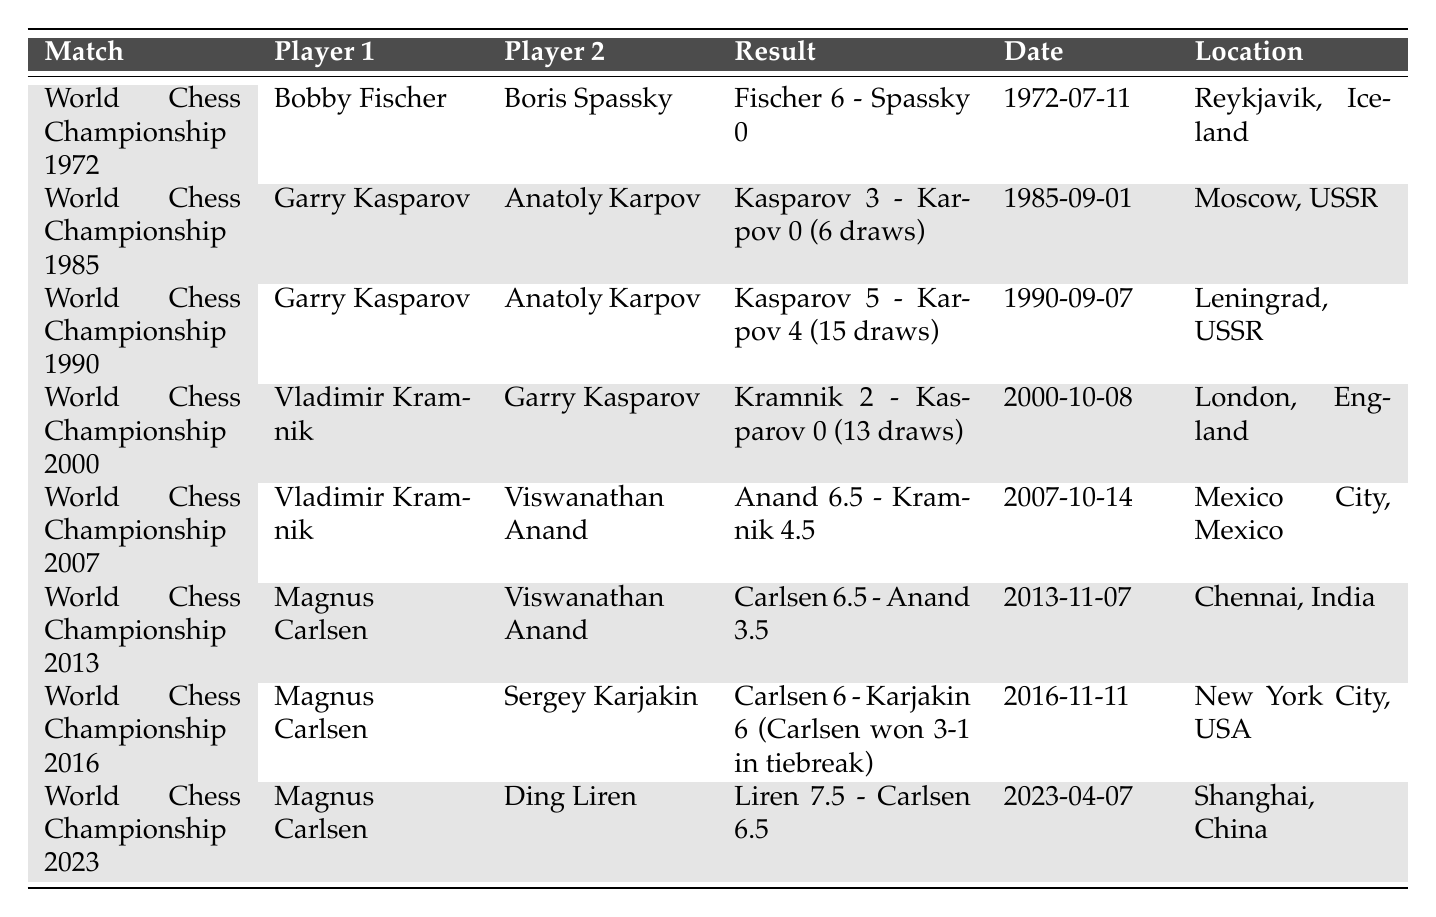What was the result of the match between Bobby Fischer and Boris Spassky? Bobby Fischer won the match with a score of 6 to 0 against Boris Spassky. This information can be found directly in the result column for the World Chess Championship 1972.
Answer: Fischer 6 - Spassky 0 Who hosted the World Chess Championship in 2007? The World Chess Championship in 2007 was hosted in Mexico City, Mexico, as indicated in the location column for that match.
Answer: Mexico City, Mexico How many draws were recorded in the World Chess Championship 1990? There were 15 draws in the match between Garry Kasparov and Anatoly Karpov during the World Chess Championship 1990, which is specified in the result column.
Answer: 15 draws What was the outcome of the World Chess Championship 2000? Vladimir Kramnik defeated Garry Kasparov with a score of 2 to 0, along with 13 draws in that championship. This result can be found in the corresponding row of the table.
Answer: Kramnik 2 - Kasparov 0 How many matches ended with a score of 6 or more points for the winner? There are three matches where the winner scored 6 or more points: 1972, 2007, and 2013. The winners, Fischer, Anand, and Carlsen, scored 6, 6.5, and 6.5 respectively.
Answer: 3 matches Which year had the most recent World Chess Championship mentioned in the table? The most recent World Chess Championship listed in the table took place in 2023. This is evident from the date column.
Answer: 2023 Did Magnus Carlsen win the World Chess Championship against Sergey Karjakin in 2016? No, Magnus Carlsen and Sergey Karjakin ended with an equal score of 6 points each; however, Carlsen won in the tiebreak. The specifics are detailed in the result for the 2016 match.
Answer: No What is the total number of matches listed in the table? The table includes a total of 8 matches, which can be counted by reviewing each row in the table.
Answer: 8 matches Which championship had the highest score margin? The World Chess Championship 1972 had the highest score margin with Fischer winning 6 to 0, which is evident when comparing the score differences in the table.
Answer: World Chess Championship 1972 Who were the players in the World Chess Championship 2016, and what was the final score? The players were Magnus Carlsen and Sergey Karjakin, and the final score was Carlsen 6 - Karjakin 6, with Carlsen winning 3-1 in tiebreak. This information is specified in their corresponding row.
Answer: Carlsen 6 - Karjakin 6 